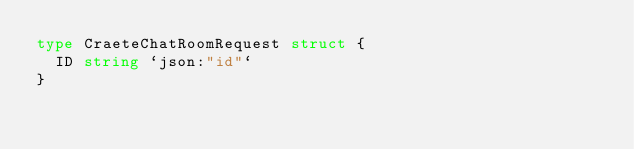Convert code to text. <code><loc_0><loc_0><loc_500><loc_500><_Go_>type CraeteChatRoomRequest struct {
	ID string `json:"id"`
}
</code> 